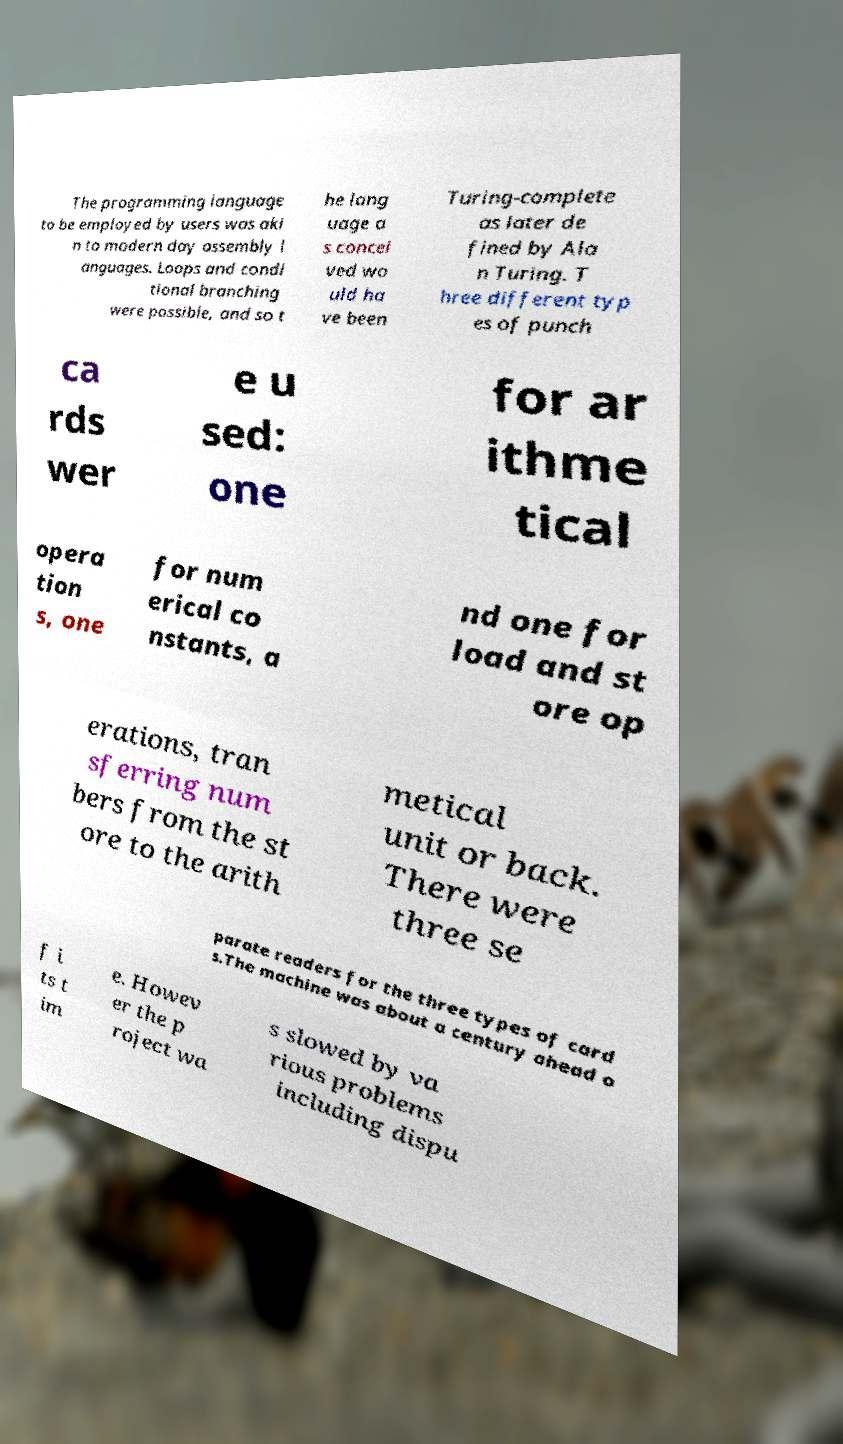Please identify and transcribe the text found in this image. The programming language to be employed by users was aki n to modern day assembly l anguages. Loops and condi tional branching were possible, and so t he lang uage a s concei ved wo uld ha ve been Turing-complete as later de fined by Ala n Turing. T hree different typ es of punch ca rds wer e u sed: one for ar ithme tical opera tion s, one for num erical co nstants, a nd one for load and st ore op erations, tran sferring num bers from the st ore to the arith metical unit or back. There were three se parate readers for the three types of card s.The machine was about a century ahead o f i ts t im e. Howev er the p roject wa s slowed by va rious problems including dispu 